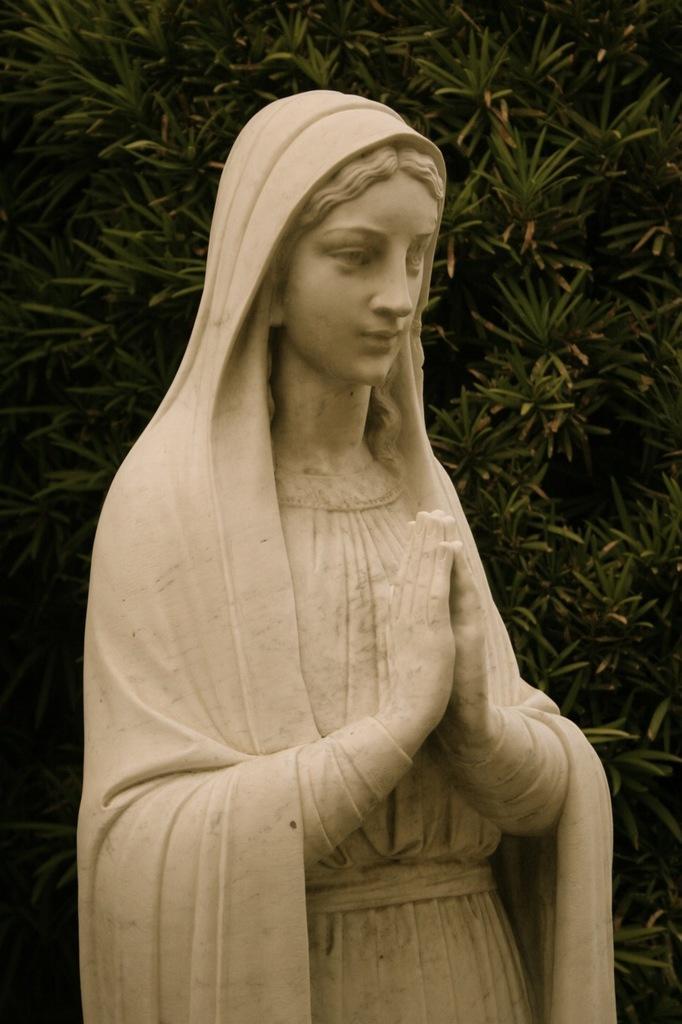How would you summarize this image in a sentence or two? In the center of the image there is a statue. In the background we can see trees. 